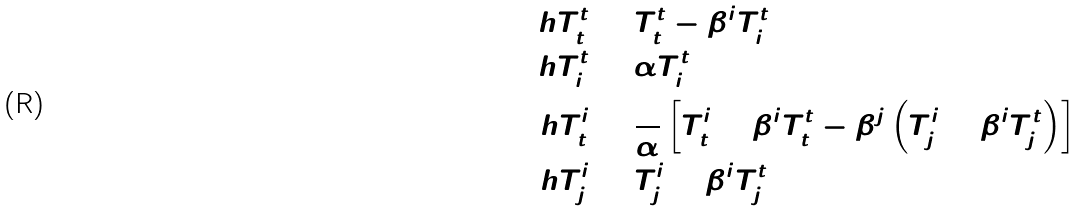Convert formula to latex. <formula><loc_0><loc_0><loc_500><loc_500>\ h { T } ^ { t } _ { t } & = T ^ { t } _ { t } - \beta ^ { i } T ^ { t } _ { i } \\ \ h { T } ^ { t } _ { i } & = \alpha T ^ { t } _ { i } \\ \ h { T } ^ { i } _ { t } & = \frac { 1 } { \alpha } \left [ T ^ { i } _ { t } + \beta ^ { i } T ^ { t } _ { t } - \beta ^ { j } \left ( T ^ { i } _ { j } + \beta ^ { i } T ^ { t } _ { j } \right ) \right ] \\ \ h { T } ^ { i } _ { j } & = T ^ { i } _ { j } + \beta ^ { i } T ^ { t } _ { j }</formula> 